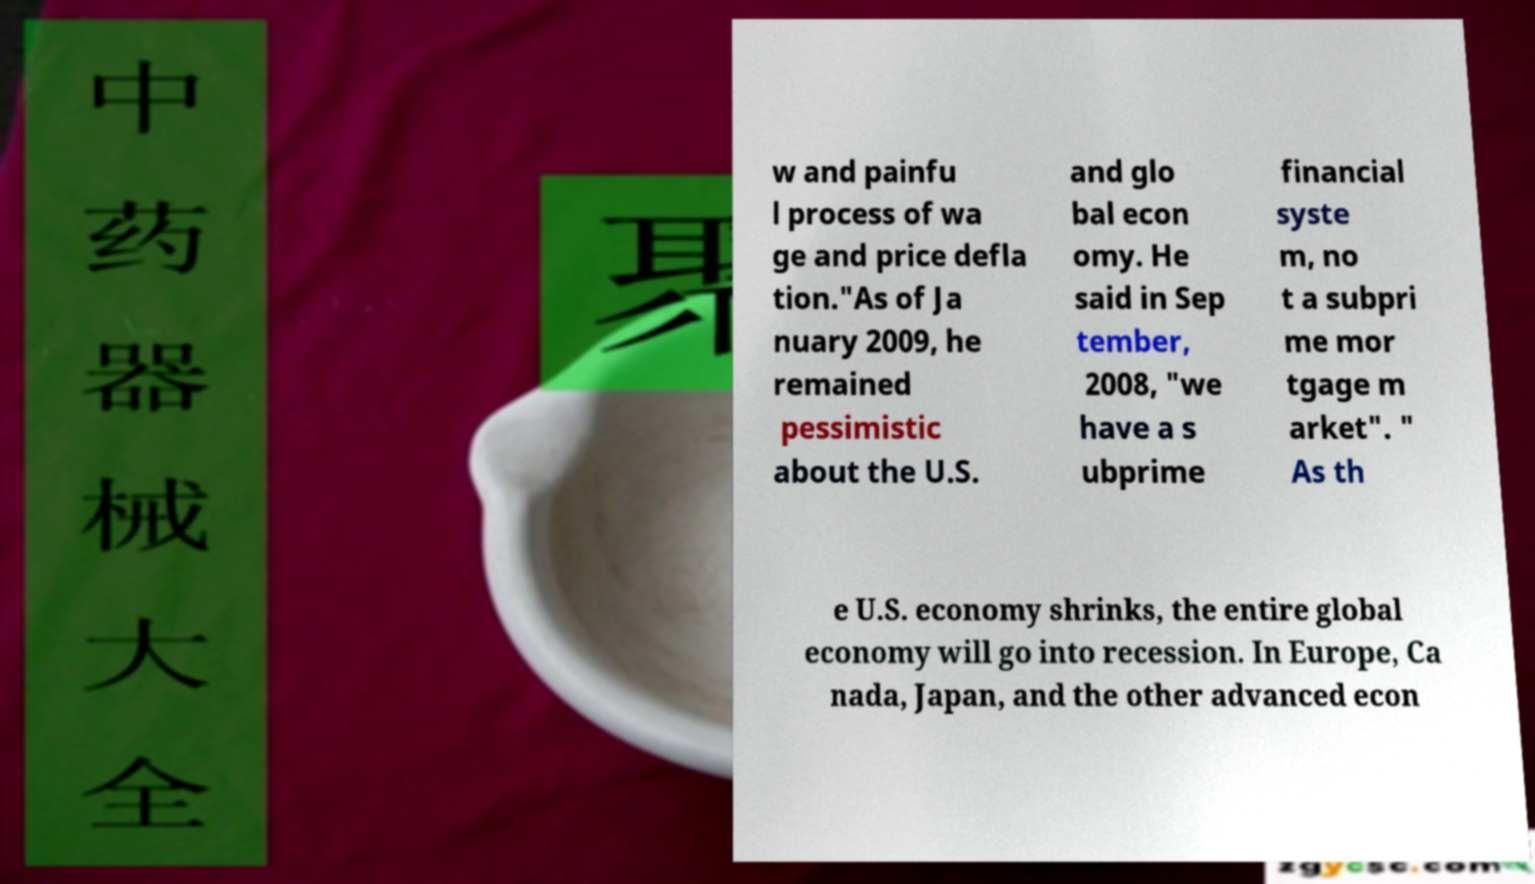There's text embedded in this image that I need extracted. Can you transcribe it verbatim? w and painfu l process of wa ge and price defla tion."As of Ja nuary 2009, he remained pessimistic about the U.S. and glo bal econ omy. He said in Sep tember, 2008, "we have a s ubprime financial syste m, no t a subpri me mor tgage m arket". " As th e U.S. economy shrinks, the entire global economy will go into recession. In Europe, Ca nada, Japan, and the other advanced econ 